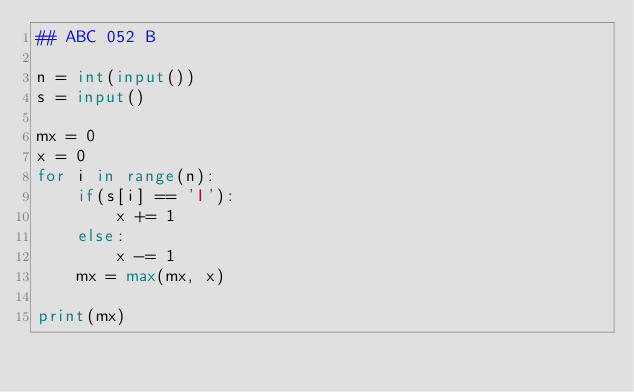<code> <loc_0><loc_0><loc_500><loc_500><_Python_>## ABC 052 B

n = int(input())
s = input()

mx = 0
x = 0
for i in range(n):
    if(s[i] == 'I'):
        x += 1
    else:
        x -= 1
    mx = max(mx, x)
    
print(mx)</code> 